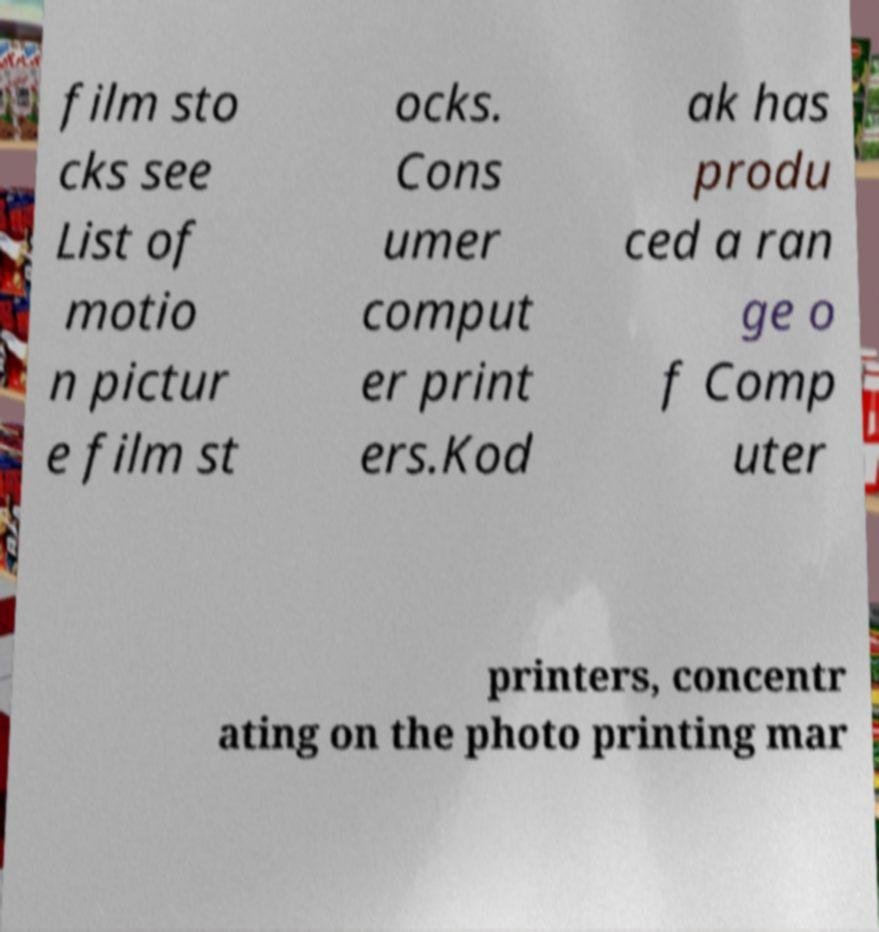For documentation purposes, I need the text within this image transcribed. Could you provide that? film sto cks see List of motio n pictur e film st ocks. Cons umer comput er print ers.Kod ak has produ ced a ran ge o f Comp uter printers, concentr ating on the photo printing mar 